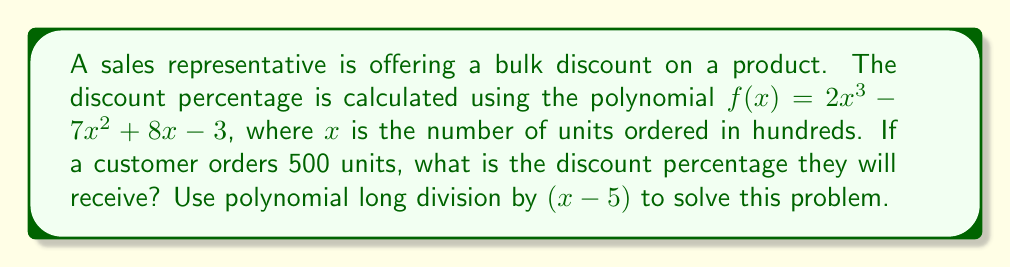Teach me how to tackle this problem. To solve this problem, we need to perform the following steps:

1) First, we need to convert 500 units to the appropriate $x$ value:
   500 units = 5 hundreds, so $x = 5$

2) We need to divide $f(x)$ by $(x-5)$ using polynomial long division:

   $$\begin{array}{r}
   2x^2 + 3x + 23 \\
   x-5 \enclose{longdiv}{2x^3 - 7x^2 + 8x - 3} \\
   \underline{2x^3 - 10x^2} \\
   3x^2 + 8x \\
   \underline{3x^2 - 15x} \\
   23x - 3 \\
   \underline{23x - 115} \\
   112
   \end{array}$$

3) The result of the division is: $2x^2 + 3x + 23$ with a remainder of 112

4) The polynomial division theorem states that:
   $f(x) = (x-5)(2x^2 + 3x + 23) + 112$

5) To find $f(5)$, we can simply evaluate the remainder:
   $f(5) = 112$

6) Therefore, the discount percentage for 500 units is 112%.
Answer: 112% 